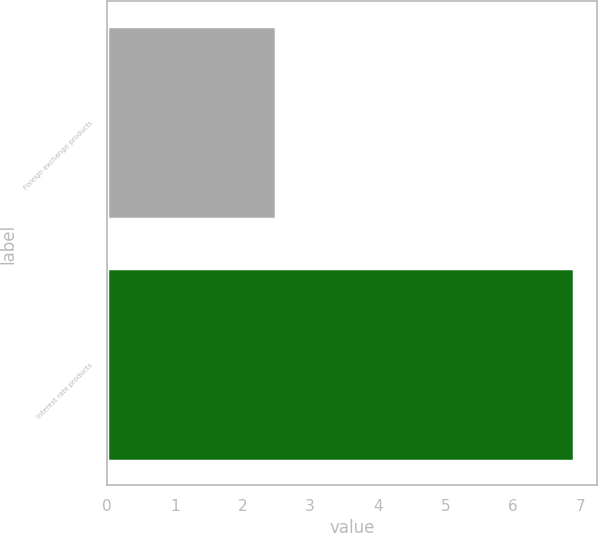<chart> <loc_0><loc_0><loc_500><loc_500><bar_chart><fcel>Foreign exchange products<fcel>Interest rate products<nl><fcel>2.5<fcel>6.9<nl></chart> 